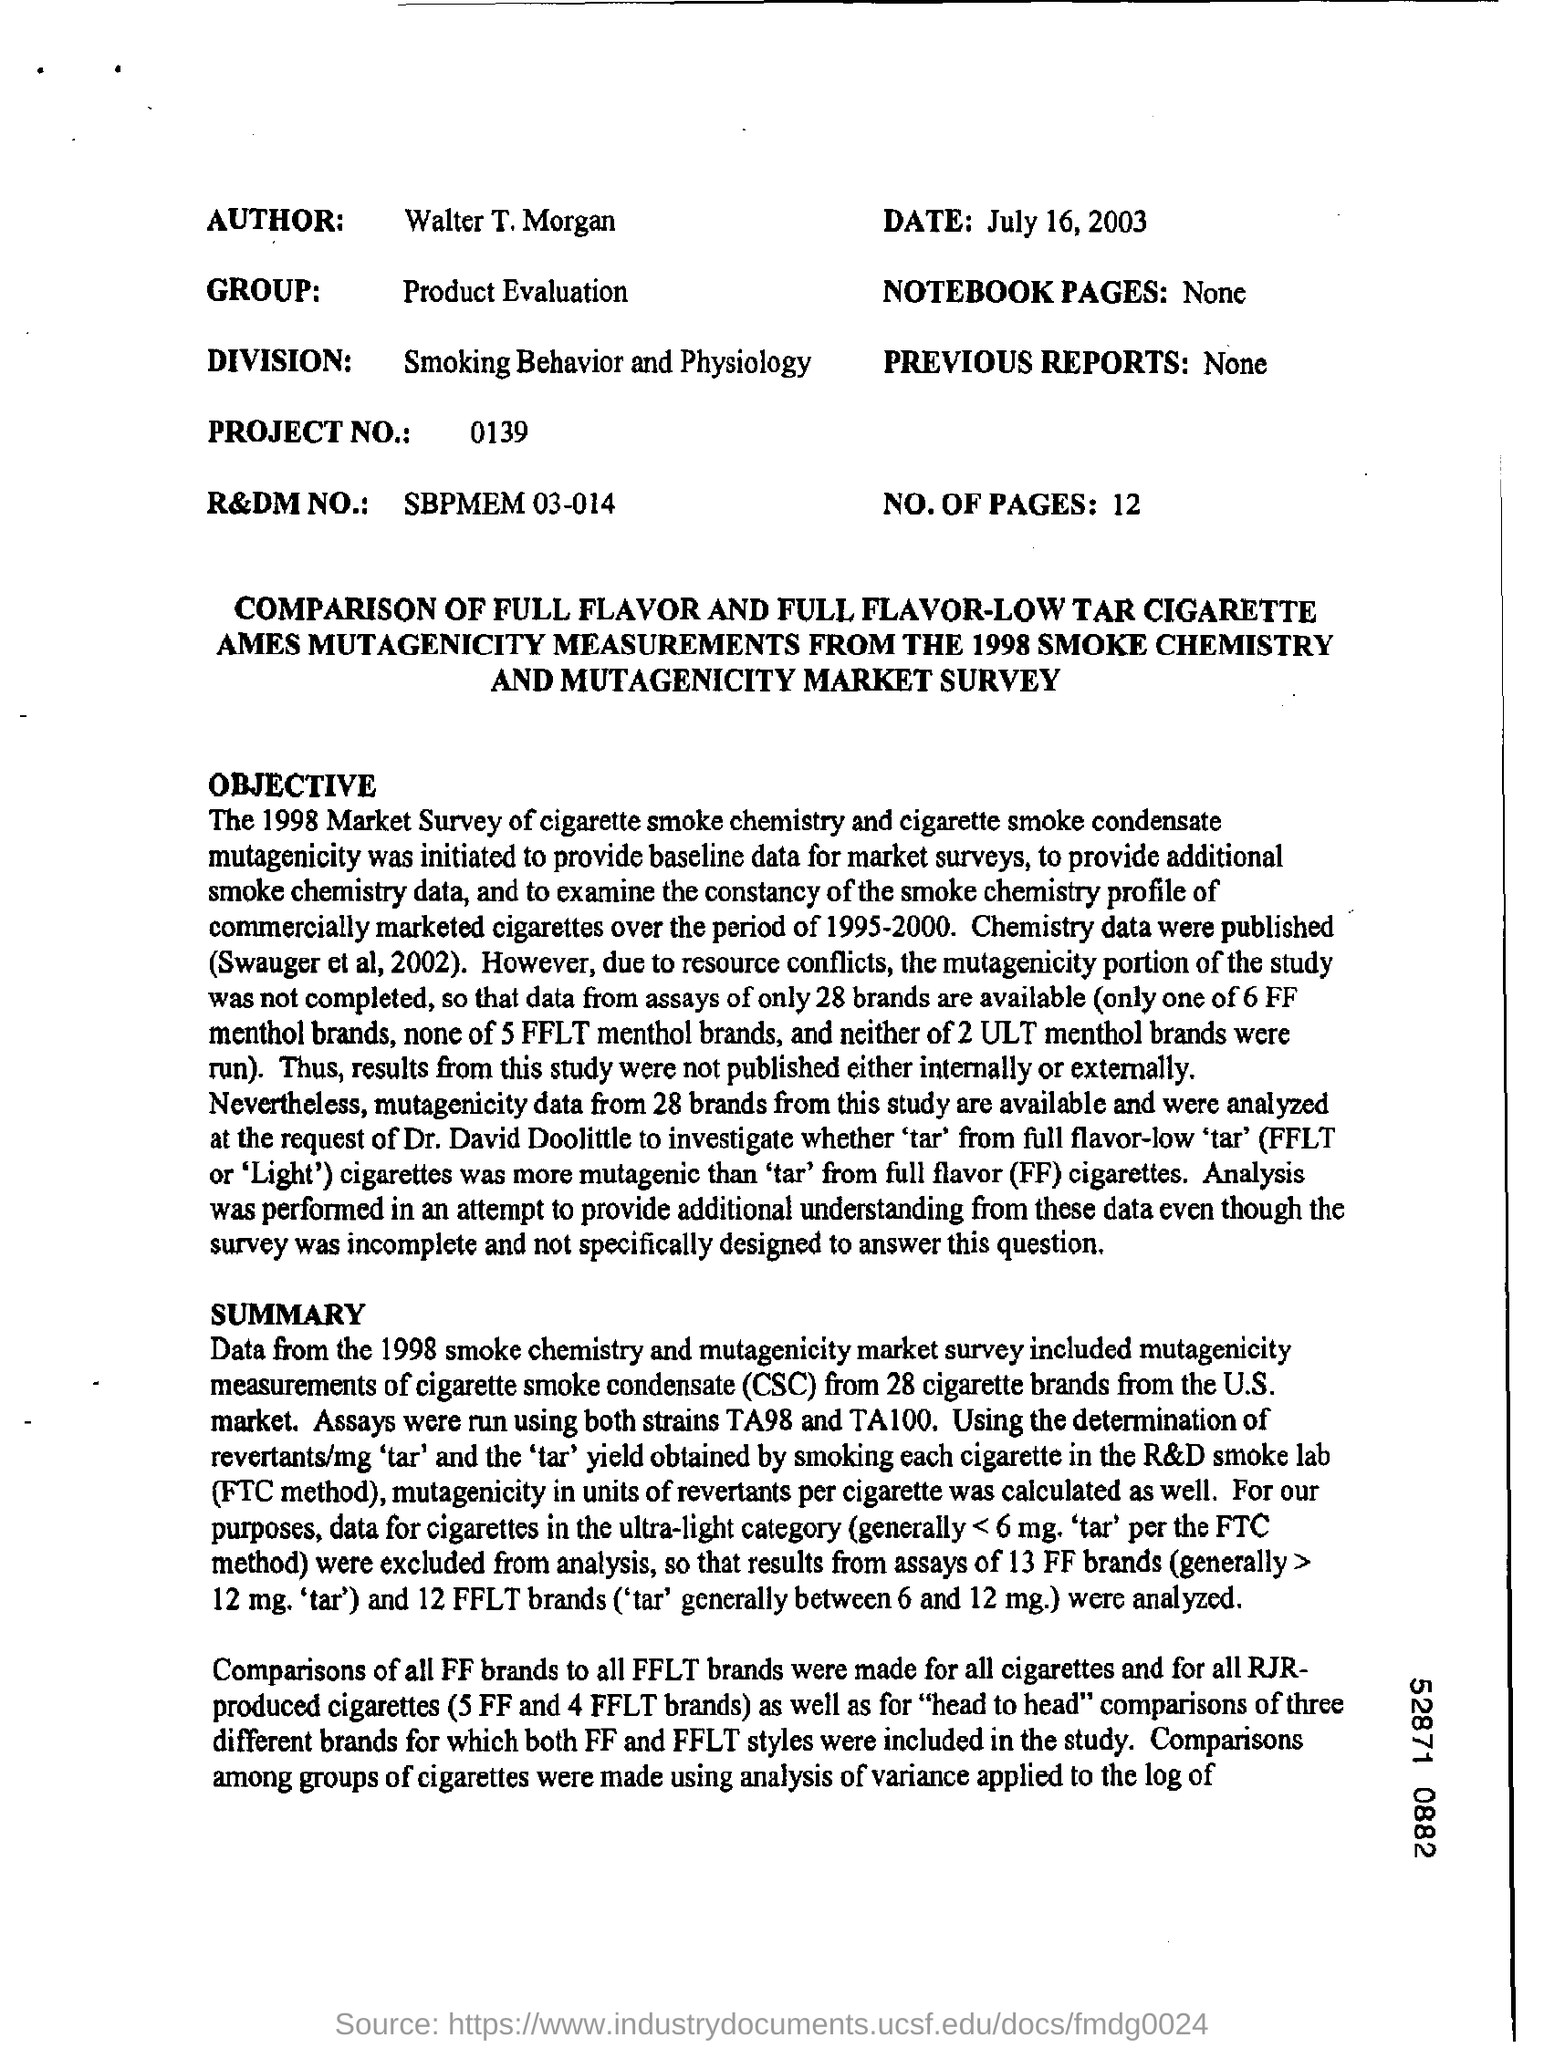Highlight a few significant elements in this photo. The sheet is dated as July 16, 2003. The project number is 0139. The number of pages mentioned is 12. The author of "Who is the author?" is Walter T. Morgan. The product evaluation group has been mentioned. 